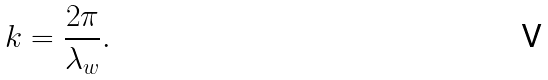Convert formula to latex. <formula><loc_0><loc_0><loc_500><loc_500>k = \frac { 2 \pi } { \lambda _ { w } } .</formula> 